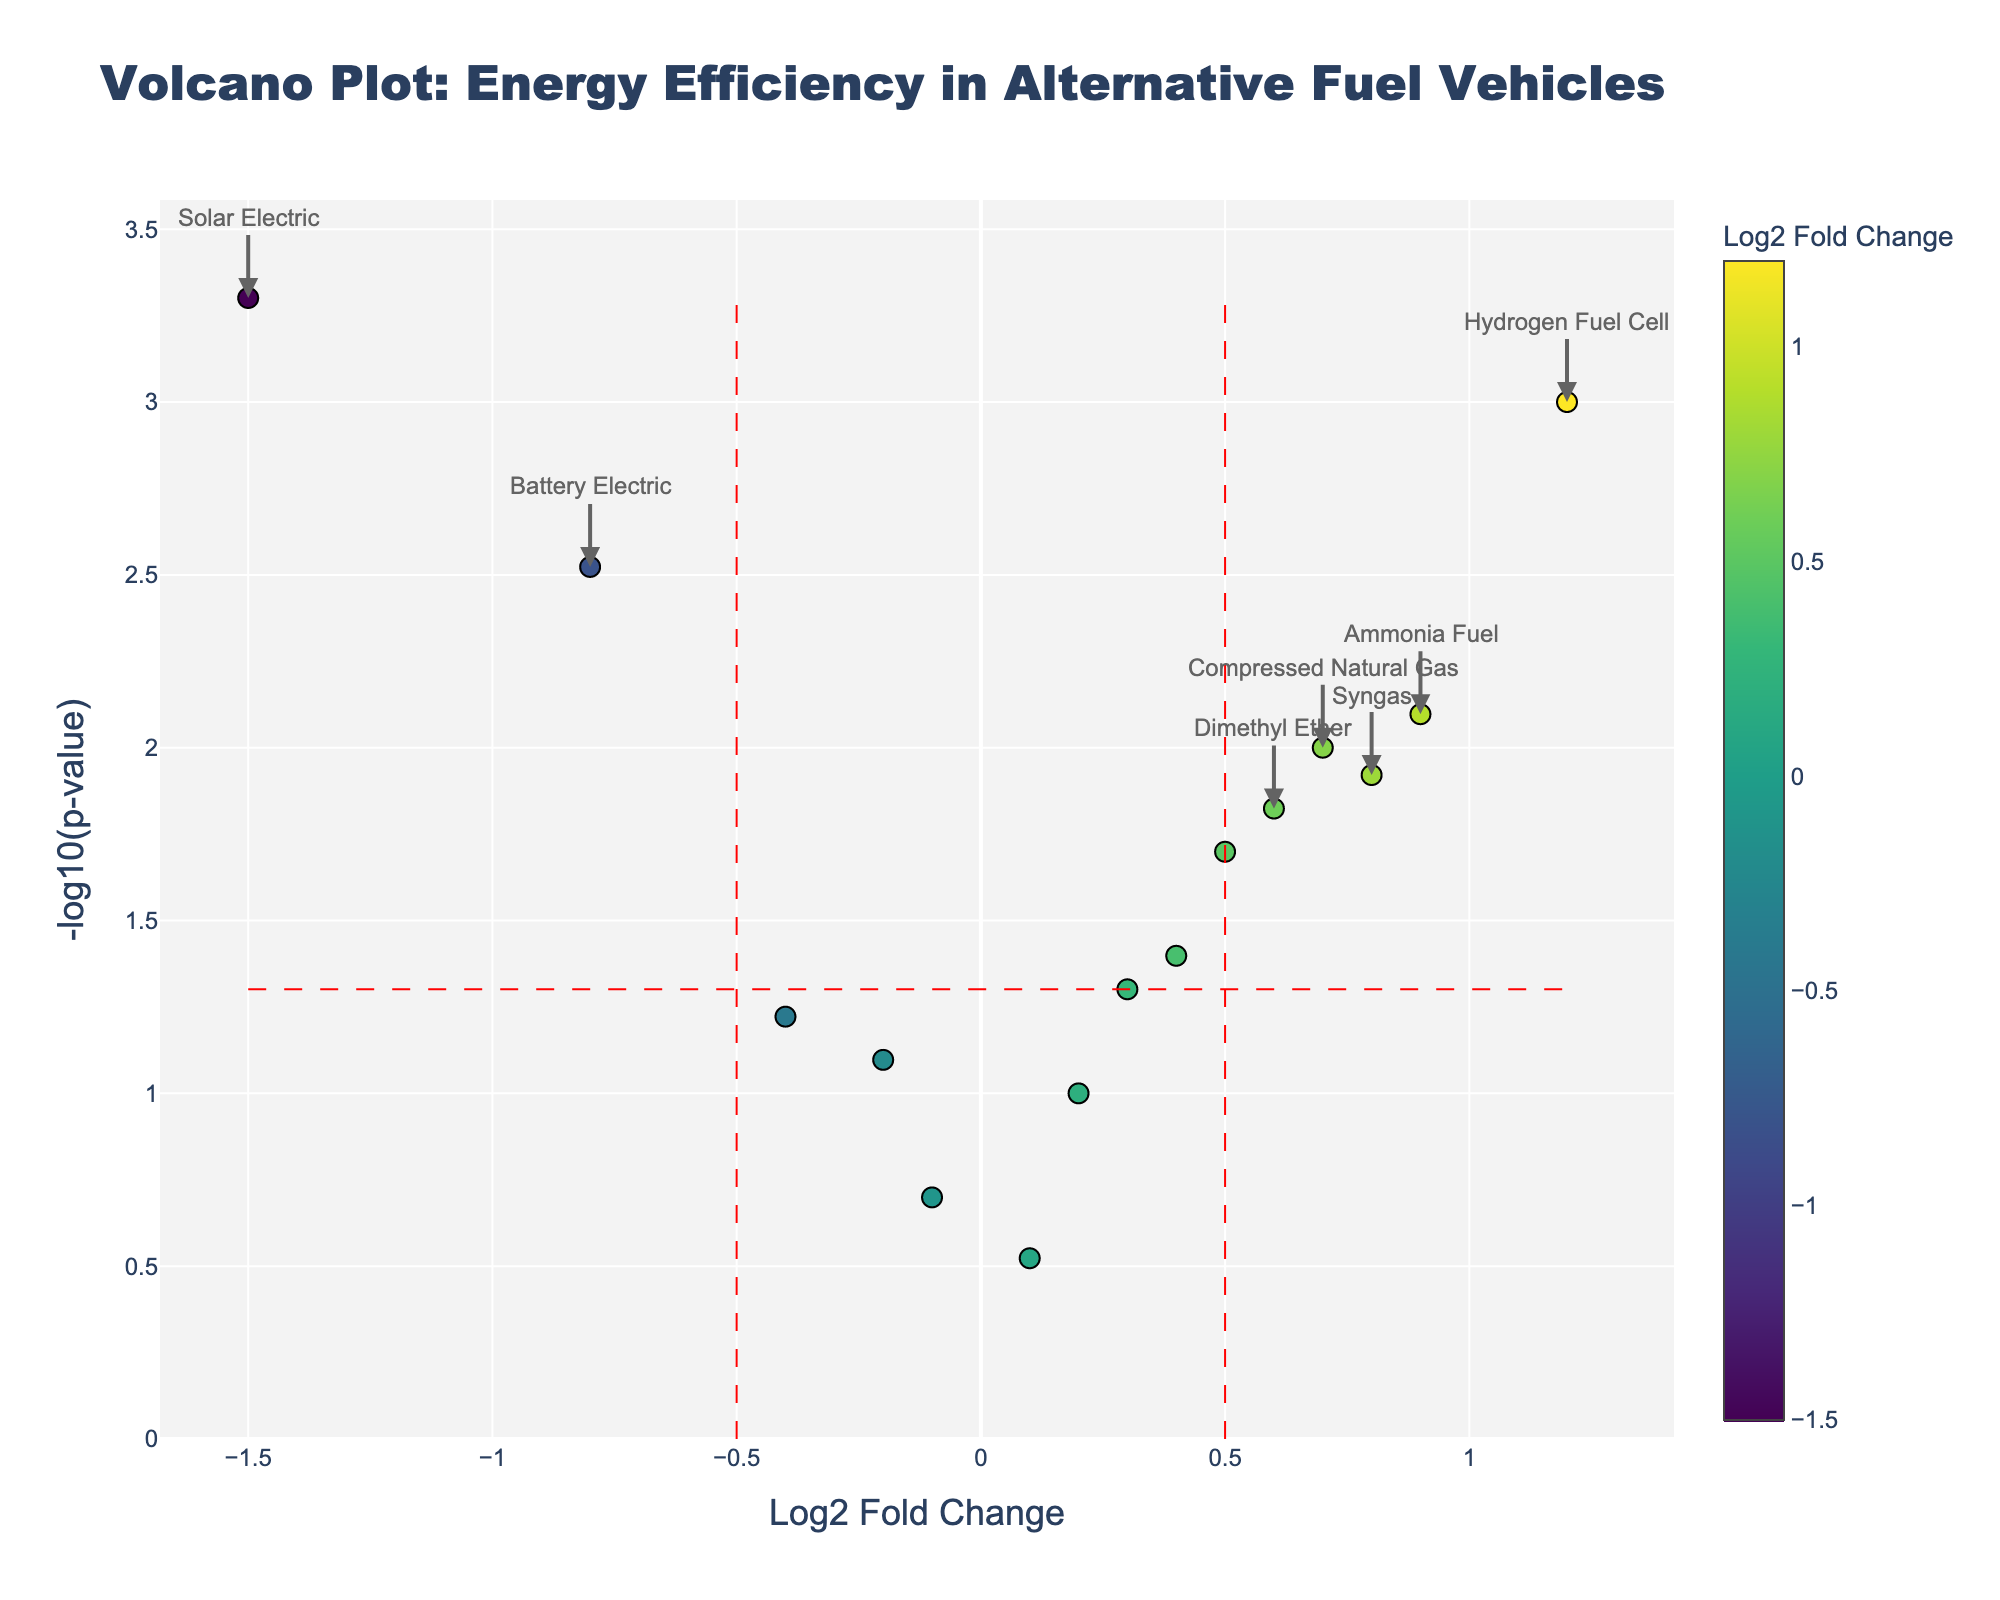How many fuel types are analyzed in the plot? Count the number of unique fuel types represented by the markers on the plot.
Answer: 15 What do the x-axis and y-axis represent in this plot? The x-axis represents the Log2 Fold Change in energy efficiency of the fuels, while the y-axis represents the -log10 of the p-value.
Answer: Log2 Fold Change (x-axis) and -log10(p-value) (y-axis) Which fuel type shows the highest increase in energy efficiency? Find the fuel type with the highest value on the x-axis (Log2 Fold Change).
Answer: Hydrogen Fuel Cell Which fuel type shows the most statistically significant decrease in energy efficiency? Look for the fuel type with the lowest Log2 Fold Change (most negative) combined with the highest -log10(p-value).
Answer: Solar Electric How can you visually identify fuel types that are statistically significant regarding their energy efficiency? Look for points that are both above the horizontal significance line (high -log10(p-value)) and outside the vertical significance lines (high absolute Log2 Fold Change).
Answer: Points outside red dashed lines What is the Log2 Fold Change and p-value of Compressed Natural Gas? Look for the data point labeled Compressed Natural Gas and refer to the x (Log2 Fold Change) and y (-log10(p-value)) values.
Answer: Log2 Fold Change 0.7, P-value 0.01 Which fuel type has a Log2 Fold Change closest to zero but is not statistically significant? Find the point closest to the vertical line at x=0 that is below the horizontal significance line.
Answer: Propane Between Battery Electric and Plug-in Hybrid, which fuel type has a lower p-value? Compare the y-axis values (-log10(p-value)) for Battery Electric and Plug-in Hybrid, the higher the y value, the lower the p-value.
Answer: Battery Electric What significance threshold is used for p-values in this plot? Refer to the horizontal red dashed line on the plot and note the y value.
Answer: 0.05 How many fuel types show a statistically significant change in energy efficiency? Count the number of data points that are both above the horizontal line (-log10(p-value)) and outside the vertical lines (Log2 Fold Change).
Answer: 7 